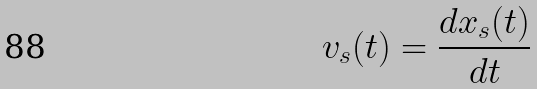Convert formula to latex. <formula><loc_0><loc_0><loc_500><loc_500>v _ { s } ( t ) = \frac { d x _ { s } ( t ) } { d t }</formula> 